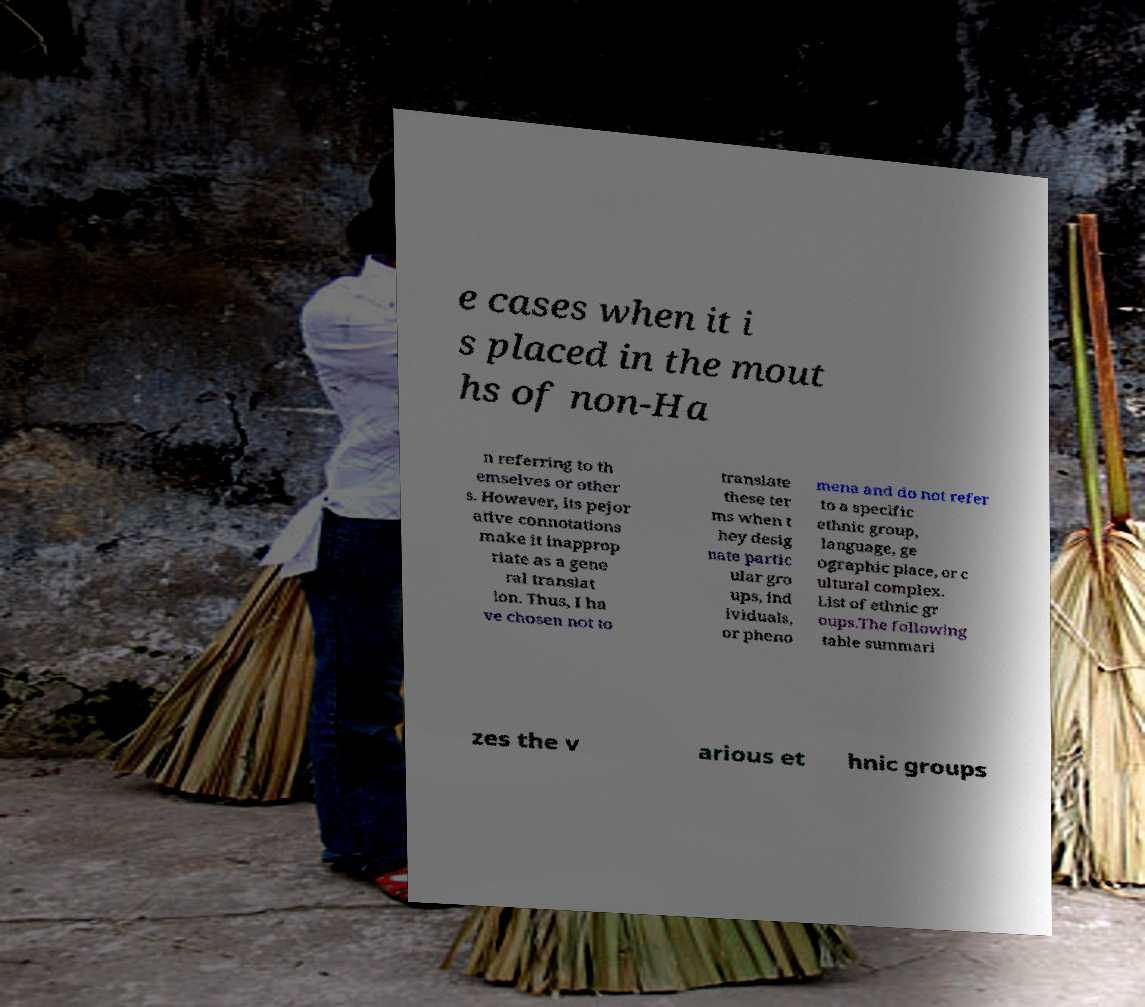For documentation purposes, I need the text within this image transcribed. Could you provide that? e cases when it i s placed in the mout hs of non-Ha n referring to th emselves or other s. However, its pejor ative connotations make it inapprop riate as a gene ral translat ion. Thus, I ha ve chosen not to translate these ter ms when t hey desig nate partic ular gro ups, ind ividuals, or pheno mena and do not refer to a specific ethnic group, language, ge ographic place, or c ultural complex. List of ethnic gr oups.The following table summari zes the v arious et hnic groups 